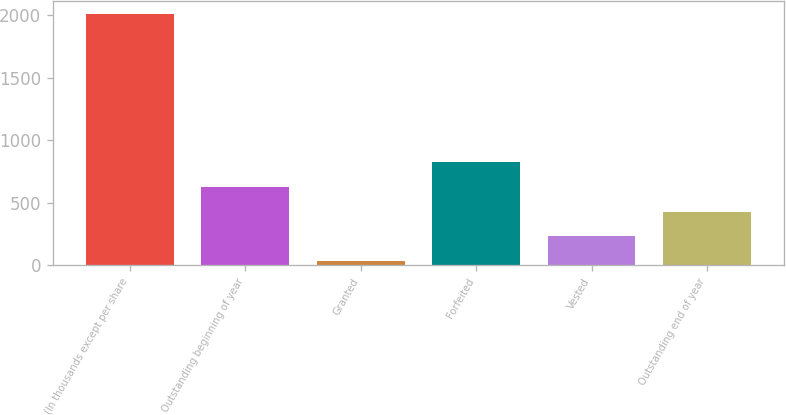Convert chart to OTSL. <chart><loc_0><loc_0><loc_500><loc_500><bar_chart><fcel>(In thousands except per share<fcel>Outstanding beginning of year<fcel>Granted<fcel>Forfeited<fcel>Vested<fcel>Outstanding end of year<nl><fcel>2010<fcel>626.41<fcel>33.46<fcel>824.06<fcel>231.11<fcel>428.76<nl></chart> 